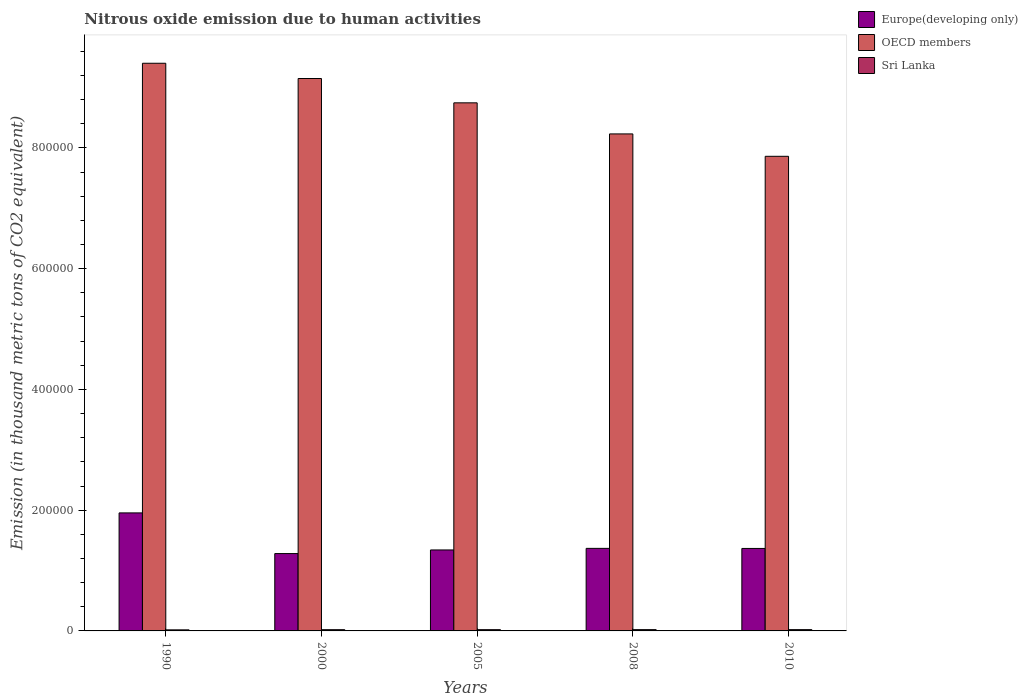How many groups of bars are there?
Give a very brief answer. 5. Are the number of bars per tick equal to the number of legend labels?
Your response must be concise. Yes. What is the label of the 3rd group of bars from the left?
Give a very brief answer. 2005. In how many cases, is the number of bars for a given year not equal to the number of legend labels?
Your answer should be very brief. 0. What is the amount of nitrous oxide emitted in Europe(developing only) in 2010?
Give a very brief answer. 1.37e+05. Across all years, what is the maximum amount of nitrous oxide emitted in Sri Lanka?
Ensure brevity in your answer.  2131.6. Across all years, what is the minimum amount of nitrous oxide emitted in OECD members?
Your response must be concise. 7.86e+05. In which year was the amount of nitrous oxide emitted in Europe(developing only) maximum?
Your response must be concise. 1990. What is the total amount of nitrous oxide emitted in Sri Lanka in the graph?
Offer a very short reply. 1.02e+04. What is the difference between the amount of nitrous oxide emitted in Europe(developing only) in 2005 and that in 2010?
Your answer should be very brief. -2503.4. What is the difference between the amount of nitrous oxide emitted in Sri Lanka in 2008 and the amount of nitrous oxide emitted in OECD members in 1990?
Your response must be concise. -9.38e+05. What is the average amount of nitrous oxide emitted in OECD members per year?
Give a very brief answer. 8.68e+05. In the year 2010, what is the difference between the amount of nitrous oxide emitted in Europe(developing only) and amount of nitrous oxide emitted in OECD members?
Provide a short and direct response. -6.49e+05. In how many years, is the amount of nitrous oxide emitted in Europe(developing only) greater than 360000 thousand metric tons?
Offer a very short reply. 0. What is the ratio of the amount of nitrous oxide emitted in OECD members in 2008 to that in 2010?
Make the answer very short. 1.05. What is the difference between the highest and the second highest amount of nitrous oxide emitted in Sri Lanka?
Offer a terse response. 6.2. What is the difference between the highest and the lowest amount of nitrous oxide emitted in Europe(developing only)?
Ensure brevity in your answer.  6.74e+04. Is the sum of the amount of nitrous oxide emitted in OECD members in 2000 and 2008 greater than the maximum amount of nitrous oxide emitted in Sri Lanka across all years?
Your response must be concise. Yes. What does the 3rd bar from the left in 2000 represents?
Keep it short and to the point. Sri Lanka. What does the 1st bar from the right in 2010 represents?
Ensure brevity in your answer.  Sri Lanka. Are all the bars in the graph horizontal?
Your response must be concise. No. How many years are there in the graph?
Offer a very short reply. 5. Does the graph contain grids?
Your answer should be very brief. No. How many legend labels are there?
Give a very brief answer. 3. What is the title of the graph?
Offer a very short reply. Nitrous oxide emission due to human activities. What is the label or title of the X-axis?
Offer a terse response. Years. What is the label or title of the Y-axis?
Keep it short and to the point. Emission (in thousand metric tons of CO2 equivalent). What is the Emission (in thousand metric tons of CO2 equivalent) in Europe(developing only) in 1990?
Your answer should be very brief. 1.95e+05. What is the Emission (in thousand metric tons of CO2 equivalent) of OECD members in 1990?
Your response must be concise. 9.40e+05. What is the Emission (in thousand metric tons of CO2 equivalent) of Sri Lanka in 1990?
Offer a very short reply. 1759.4. What is the Emission (in thousand metric tons of CO2 equivalent) in Europe(developing only) in 2000?
Provide a short and direct response. 1.28e+05. What is the Emission (in thousand metric tons of CO2 equivalent) in OECD members in 2000?
Offer a terse response. 9.15e+05. What is the Emission (in thousand metric tons of CO2 equivalent) of Sri Lanka in 2000?
Provide a succinct answer. 2044.5. What is the Emission (in thousand metric tons of CO2 equivalent) of Europe(developing only) in 2005?
Keep it short and to the point. 1.34e+05. What is the Emission (in thousand metric tons of CO2 equivalent) of OECD members in 2005?
Offer a terse response. 8.75e+05. What is the Emission (in thousand metric tons of CO2 equivalent) of Sri Lanka in 2005?
Keep it short and to the point. 2094.1. What is the Emission (in thousand metric tons of CO2 equivalent) of Europe(developing only) in 2008?
Your answer should be compact. 1.37e+05. What is the Emission (in thousand metric tons of CO2 equivalent) in OECD members in 2008?
Give a very brief answer. 8.23e+05. What is the Emission (in thousand metric tons of CO2 equivalent) in Sri Lanka in 2008?
Make the answer very short. 2125.4. What is the Emission (in thousand metric tons of CO2 equivalent) in Europe(developing only) in 2010?
Your answer should be very brief. 1.37e+05. What is the Emission (in thousand metric tons of CO2 equivalent) in OECD members in 2010?
Give a very brief answer. 7.86e+05. What is the Emission (in thousand metric tons of CO2 equivalent) in Sri Lanka in 2010?
Keep it short and to the point. 2131.6. Across all years, what is the maximum Emission (in thousand metric tons of CO2 equivalent) of Europe(developing only)?
Ensure brevity in your answer.  1.95e+05. Across all years, what is the maximum Emission (in thousand metric tons of CO2 equivalent) of OECD members?
Your answer should be very brief. 9.40e+05. Across all years, what is the maximum Emission (in thousand metric tons of CO2 equivalent) of Sri Lanka?
Give a very brief answer. 2131.6. Across all years, what is the minimum Emission (in thousand metric tons of CO2 equivalent) in Europe(developing only)?
Your answer should be very brief. 1.28e+05. Across all years, what is the minimum Emission (in thousand metric tons of CO2 equivalent) in OECD members?
Ensure brevity in your answer.  7.86e+05. Across all years, what is the minimum Emission (in thousand metric tons of CO2 equivalent) in Sri Lanka?
Give a very brief answer. 1759.4. What is the total Emission (in thousand metric tons of CO2 equivalent) of Europe(developing only) in the graph?
Make the answer very short. 7.31e+05. What is the total Emission (in thousand metric tons of CO2 equivalent) in OECD members in the graph?
Your answer should be very brief. 4.34e+06. What is the total Emission (in thousand metric tons of CO2 equivalent) in Sri Lanka in the graph?
Your response must be concise. 1.02e+04. What is the difference between the Emission (in thousand metric tons of CO2 equivalent) of Europe(developing only) in 1990 and that in 2000?
Offer a very short reply. 6.74e+04. What is the difference between the Emission (in thousand metric tons of CO2 equivalent) of OECD members in 1990 and that in 2000?
Your response must be concise. 2.52e+04. What is the difference between the Emission (in thousand metric tons of CO2 equivalent) in Sri Lanka in 1990 and that in 2000?
Your answer should be compact. -285.1. What is the difference between the Emission (in thousand metric tons of CO2 equivalent) of Europe(developing only) in 1990 and that in 2005?
Your response must be concise. 6.14e+04. What is the difference between the Emission (in thousand metric tons of CO2 equivalent) in OECD members in 1990 and that in 2005?
Provide a succinct answer. 6.55e+04. What is the difference between the Emission (in thousand metric tons of CO2 equivalent) of Sri Lanka in 1990 and that in 2005?
Provide a short and direct response. -334.7. What is the difference between the Emission (in thousand metric tons of CO2 equivalent) of Europe(developing only) in 1990 and that in 2008?
Offer a terse response. 5.87e+04. What is the difference between the Emission (in thousand metric tons of CO2 equivalent) in OECD members in 1990 and that in 2008?
Your answer should be compact. 1.17e+05. What is the difference between the Emission (in thousand metric tons of CO2 equivalent) of Sri Lanka in 1990 and that in 2008?
Give a very brief answer. -366. What is the difference between the Emission (in thousand metric tons of CO2 equivalent) in Europe(developing only) in 1990 and that in 2010?
Offer a very short reply. 5.89e+04. What is the difference between the Emission (in thousand metric tons of CO2 equivalent) of OECD members in 1990 and that in 2010?
Make the answer very short. 1.54e+05. What is the difference between the Emission (in thousand metric tons of CO2 equivalent) in Sri Lanka in 1990 and that in 2010?
Your answer should be very brief. -372.2. What is the difference between the Emission (in thousand metric tons of CO2 equivalent) of Europe(developing only) in 2000 and that in 2005?
Keep it short and to the point. -5992.3. What is the difference between the Emission (in thousand metric tons of CO2 equivalent) of OECD members in 2000 and that in 2005?
Ensure brevity in your answer.  4.03e+04. What is the difference between the Emission (in thousand metric tons of CO2 equivalent) in Sri Lanka in 2000 and that in 2005?
Make the answer very short. -49.6. What is the difference between the Emission (in thousand metric tons of CO2 equivalent) of Europe(developing only) in 2000 and that in 2008?
Offer a very short reply. -8618.7. What is the difference between the Emission (in thousand metric tons of CO2 equivalent) of OECD members in 2000 and that in 2008?
Offer a terse response. 9.18e+04. What is the difference between the Emission (in thousand metric tons of CO2 equivalent) in Sri Lanka in 2000 and that in 2008?
Your answer should be compact. -80.9. What is the difference between the Emission (in thousand metric tons of CO2 equivalent) of Europe(developing only) in 2000 and that in 2010?
Offer a very short reply. -8495.7. What is the difference between the Emission (in thousand metric tons of CO2 equivalent) of OECD members in 2000 and that in 2010?
Offer a very short reply. 1.29e+05. What is the difference between the Emission (in thousand metric tons of CO2 equivalent) in Sri Lanka in 2000 and that in 2010?
Provide a short and direct response. -87.1. What is the difference between the Emission (in thousand metric tons of CO2 equivalent) in Europe(developing only) in 2005 and that in 2008?
Offer a very short reply. -2626.4. What is the difference between the Emission (in thousand metric tons of CO2 equivalent) of OECD members in 2005 and that in 2008?
Your response must be concise. 5.15e+04. What is the difference between the Emission (in thousand metric tons of CO2 equivalent) in Sri Lanka in 2005 and that in 2008?
Your answer should be compact. -31.3. What is the difference between the Emission (in thousand metric tons of CO2 equivalent) of Europe(developing only) in 2005 and that in 2010?
Your answer should be compact. -2503.4. What is the difference between the Emission (in thousand metric tons of CO2 equivalent) in OECD members in 2005 and that in 2010?
Ensure brevity in your answer.  8.86e+04. What is the difference between the Emission (in thousand metric tons of CO2 equivalent) in Sri Lanka in 2005 and that in 2010?
Offer a terse response. -37.5. What is the difference between the Emission (in thousand metric tons of CO2 equivalent) in Europe(developing only) in 2008 and that in 2010?
Offer a very short reply. 123. What is the difference between the Emission (in thousand metric tons of CO2 equivalent) in OECD members in 2008 and that in 2010?
Provide a succinct answer. 3.71e+04. What is the difference between the Emission (in thousand metric tons of CO2 equivalent) in Europe(developing only) in 1990 and the Emission (in thousand metric tons of CO2 equivalent) in OECD members in 2000?
Your answer should be compact. -7.19e+05. What is the difference between the Emission (in thousand metric tons of CO2 equivalent) of Europe(developing only) in 1990 and the Emission (in thousand metric tons of CO2 equivalent) of Sri Lanka in 2000?
Offer a terse response. 1.93e+05. What is the difference between the Emission (in thousand metric tons of CO2 equivalent) in OECD members in 1990 and the Emission (in thousand metric tons of CO2 equivalent) in Sri Lanka in 2000?
Ensure brevity in your answer.  9.38e+05. What is the difference between the Emission (in thousand metric tons of CO2 equivalent) of Europe(developing only) in 1990 and the Emission (in thousand metric tons of CO2 equivalent) of OECD members in 2005?
Your response must be concise. -6.79e+05. What is the difference between the Emission (in thousand metric tons of CO2 equivalent) of Europe(developing only) in 1990 and the Emission (in thousand metric tons of CO2 equivalent) of Sri Lanka in 2005?
Keep it short and to the point. 1.93e+05. What is the difference between the Emission (in thousand metric tons of CO2 equivalent) of OECD members in 1990 and the Emission (in thousand metric tons of CO2 equivalent) of Sri Lanka in 2005?
Your answer should be very brief. 9.38e+05. What is the difference between the Emission (in thousand metric tons of CO2 equivalent) in Europe(developing only) in 1990 and the Emission (in thousand metric tons of CO2 equivalent) in OECD members in 2008?
Keep it short and to the point. -6.28e+05. What is the difference between the Emission (in thousand metric tons of CO2 equivalent) in Europe(developing only) in 1990 and the Emission (in thousand metric tons of CO2 equivalent) in Sri Lanka in 2008?
Give a very brief answer. 1.93e+05. What is the difference between the Emission (in thousand metric tons of CO2 equivalent) of OECD members in 1990 and the Emission (in thousand metric tons of CO2 equivalent) of Sri Lanka in 2008?
Provide a short and direct response. 9.38e+05. What is the difference between the Emission (in thousand metric tons of CO2 equivalent) in Europe(developing only) in 1990 and the Emission (in thousand metric tons of CO2 equivalent) in OECD members in 2010?
Give a very brief answer. -5.91e+05. What is the difference between the Emission (in thousand metric tons of CO2 equivalent) in Europe(developing only) in 1990 and the Emission (in thousand metric tons of CO2 equivalent) in Sri Lanka in 2010?
Your response must be concise. 1.93e+05. What is the difference between the Emission (in thousand metric tons of CO2 equivalent) of OECD members in 1990 and the Emission (in thousand metric tons of CO2 equivalent) of Sri Lanka in 2010?
Offer a terse response. 9.38e+05. What is the difference between the Emission (in thousand metric tons of CO2 equivalent) in Europe(developing only) in 2000 and the Emission (in thousand metric tons of CO2 equivalent) in OECD members in 2005?
Keep it short and to the point. -7.47e+05. What is the difference between the Emission (in thousand metric tons of CO2 equivalent) of Europe(developing only) in 2000 and the Emission (in thousand metric tons of CO2 equivalent) of Sri Lanka in 2005?
Your answer should be compact. 1.26e+05. What is the difference between the Emission (in thousand metric tons of CO2 equivalent) of OECD members in 2000 and the Emission (in thousand metric tons of CO2 equivalent) of Sri Lanka in 2005?
Your response must be concise. 9.13e+05. What is the difference between the Emission (in thousand metric tons of CO2 equivalent) in Europe(developing only) in 2000 and the Emission (in thousand metric tons of CO2 equivalent) in OECD members in 2008?
Your answer should be very brief. -6.95e+05. What is the difference between the Emission (in thousand metric tons of CO2 equivalent) in Europe(developing only) in 2000 and the Emission (in thousand metric tons of CO2 equivalent) in Sri Lanka in 2008?
Make the answer very short. 1.26e+05. What is the difference between the Emission (in thousand metric tons of CO2 equivalent) of OECD members in 2000 and the Emission (in thousand metric tons of CO2 equivalent) of Sri Lanka in 2008?
Your answer should be very brief. 9.13e+05. What is the difference between the Emission (in thousand metric tons of CO2 equivalent) of Europe(developing only) in 2000 and the Emission (in thousand metric tons of CO2 equivalent) of OECD members in 2010?
Give a very brief answer. -6.58e+05. What is the difference between the Emission (in thousand metric tons of CO2 equivalent) in Europe(developing only) in 2000 and the Emission (in thousand metric tons of CO2 equivalent) in Sri Lanka in 2010?
Make the answer very short. 1.26e+05. What is the difference between the Emission (in thousand metric tons of CO2 equivalent) of OECD members in 2000 and the Emission (in thousand metric tons of CO2 equivalent) of Sri Lanka in 2010?
Your answer should be very brief. 9.13e+05. What is the difference between the Emission (in thousand metric tons of CO2 equivalent) in Europe(developing only) in 2005 and the Emission (in thousand metric tons of CO2 equivalent) in OECD members in 2008?
Offer a terse response. -6.89e+05. What is the difference between the Emission (in thousand metric tons of CO2 equivalent) of Europe(developing only) in 2005 and the Emission (in thousand metric tons of CO2 equivalent) of Sri Lanka in 2008?
Your answer should be very brief. 1.32e+05. What is the difference between the Emission (in thousand metric tons of CO2 equivalent) in OECD members in 2005 and the Emission (in thousand metric tons of CO2 equivalent) in Sri Lanka in 2008?
Provide a succinct answer. 8.72e+05. What is the difference between the Emission (in thousand metric tons of CO2 equivalent) of Europe(developing only) in 2005 and the Emission (in thousand metric tons of CO2 equivalent) of OECD members in 2010?
Ensure brevity in your answer.  -6.52e+05. What is the difference between the Emission (in thousand metric tons of CO2 equivalent) in Europe(developing only) in 2005 and the Emission (in thousand metric tons of CO2 equivalent) in Sri Lanka in 2010?
Provide a succinct answer. 1.32e+05. What is the difference between the Emission (in thousand metric tons of CO2 equivalent) of OECD members in 2005 and the Emission (in thousand metric tons of CO2 equivalent) of Sri Lanka in 2010?
Ensure brevity in your answer.  8.72e+05. What is the difference between the Emission (in thousand metric tons of CO2 equivalent) of Europe(developing only) in 2008 and the Emission (in thousand metric tons of CO2 equivalent) of OECD members in 2010?
Provide a succinct answer. -6.49e+05. What is the difference between the Emission (in thousand metric tons of CO2 equivalent) of Europe(developing only) in 2008 and the Emission (in thousand metric tons of CO2 equivalent) of Sri Lanka in 2010?
Give a very brief answer. 1.35e+05. What is the difference between the Emission (in thousand metric tons of CO2 equivalent) in OECD members in 2008 and the Emission (in thousand metric tons of CO2 equivalent) in Sri Lanka in 2010?
Make the answer very short. 8.21e+05. What is the average Emission (in thousand metric tons of CO2 equivalent) of Europe(developing only) per year?
Ensure brevity in your answer.  1.46e+05. What is the average Emission (in thousand metric tons of CO2 equivalent) of OECD members per year?
Make the answer very short. 8.68e+05. What is the average Emission (in thousand metric tons of CO2 equivalent) of Sri Lanka per year?
Provide a succinct answer. 2031. In the year 1990, what is the difference between the Emission (in thousand metric tons of CO2 equivalent) in Europe(developing only) and Emission (in thousand metric tons of CO2 equivalent) in OECD members?
Provide a short and direct response. -7.45e+05. In the year 1990, what is the difference between the Emission (in thousand metric tons of CO2 equivalent) in Europe(developing only) and Emission (in thousand metric tons of CO2 equivalent) in Sri Lanka?
Your answer should be compact. 1.94e+05. In the year 1990, what is the difference between the Emission (in thousand metric tons of CO2 equivalent) in OECD members and Emission (in thousand metric tons of CO2 equivalent) in Sri Lanka?
Give a very brief answer. 9.38e+05. In the year 2000, what is the difference between the Emission (in thousand metric tons of CO2 equivalent) in Europe(developing only) and Emission (in thousand metric tons of CO2 equivalent) in OECD members?
Your answer should be compact. -7.87e+05. In the year 2000, what is the difference between the Emission (in thousand metric tons of CO2 equivalent) of Europe(developing only) and Emission (in thousand metric tons of CO2 equivalent) of Sri Lanka?
Make the answer very short. 1.26e+05. In the year 2000, what is the difference between the Emission (in thousand metric tons of CO2 equivalent) of OECD members and Emission (in thousand metric tons of CO2 equivalent) of Sri Lanka?
Make the answer very short. 9.13e+05. In the year 2005, what is the difference between the Emission (in thousand metric tons of CO2 equivalent) in Europe(developing only) and Emission (in thousand metric tons of CO2 equivalent) in OECD members?
Provide a short and direct response. -7.41e+05. In the year 2005, what is the difference between the Emission (in thousand metric tons of CO2 equivalent) of Europe(developing only) and Emission (in thousand metric tons of CO2 equivalent) of Sri Lanka?
Your answer should be very brief. 1.32e+05. In the year 2005, what is the difference between the Emission (in thousand metric tons of CO2 equivalent) in OECD members and Emission (in thousand metric tons of CO2 equivalent) in Sri Lanka?
Your answer should be compact. 8.73e+05. In the year 2008, what is the difference between the Emission (in thousand metric tons of CO2 equivalent) of Europe(developing only) and Emission (in thousand metric tons of CO2 equivalent) of OECD members?
Offer a very short reply. -6.86e+05. In the year 2008, what is the difference between the Emission (in thousand metric tons of CO2 equivalent) in Europe(developing only) and Emission (in thousand metric tons of CO2 equivalent) in Sri Lanka?
Make the answer very short. 1.35e+05. In the year 2008, what is the difference between the Emission (in thousand metric tons of CO2 equivalent) of OECD members and Emission (in thousand metric tons of CO2 equivalent) of Sri Lanka?
Keep it short and to the point. 8.21e+05. In the year 2010, what is the difference between the Emission (in thousand metric tons of CO2 equivalent) in Europe(developing only) and Emission (in thousand metric tons of CO2 equivalent) in OECD members?
Ensure brevity in your answer.  -6.49e+05. In the year 2010, what is the difference between the Emission (in thousand metric tons of CO2 equivalent) of Europe(developing only) and Emission (in thousand metric tons of CO2 equivalent) of Sri Lanka?
Your answer should be very brief. 1.34e+05. In the year 2010, what is the difference between the Emission (in thousand metric tons of CO2 equivalent) of OECD members and Emission (in thousand metric tons of CO2 equivalent) of Sri Lanka?
Your response must be concise. 7.84e+05. What is the ratio of the Emission (in thousand metric tons of CO2 equivalent) of Europe(developing only) in 1990 to that in 2000?
Your answer should be compact. 1.53. What is the ratio of the Emission (in thousand metric tons of CO2 equivalent) of OECD members in 1990 to that in 2000?
Make the answer very short. 1.03. What is the ratio of the Emission (in thousand metric tons of CO2 equivalent) of Sri Lanka in 1990 to that in 2000?
Give a very brief answer. 0.86. What is the ratio of the Emission (in thousand metric tons of CO2 equivalent) of Europe(developing only) in 1990 to that in 2005?
Provide a short and direct response. 1.46. What is the ratio of the Emission (in thousand metric tons of CO2 equivalent) in OECD members in 1990 to that in 2005?
Your answer should be compact. 1.07. What is the ratio of the Emission (in thousand metric tons of CO2 equivalent) in Sri Lanka in 1990 to that in 2005?
Make the answer very short. 0.84. What is the ratio of the Emission (in thousand metric tons of CO2 equivalent) of Europe(developing only) in 1990 to that in 2008?
Offer a very short reply. 1.43. What is the ratio of the Emission (in thousand metric tons of CO2 equivalent) of OECD members in 1990 to that in 2008?
Offer a very short reply. 1.14. What is the ratio of the Emission (in thousand metric tons of CO2 equivalent) of Sri Lanka in 1990 to that in 2008?
Your response must be concise. 0.83. What is the ratio of the Emission (in thousand metric tons of CO2 equivalent) in Europe(developing only) in 1990 to that in 2010?
Your answer should be very brief. 1.43. What is the ratio of the Emission (in thousand metric tons of CO2 equivalent) in OECD members in 1990 to that in 2010?
Give a very brief answer. 1.2. What is the ratio of the Emission (in thousand metric tons of CO2 equivalent) of Sri Lanka in 1990 to that in 2010?
Your response must be concise. 0.83. What is the ratio of the Emission (in thousand metric tons of CO2 equivalent) in Europe(developing only) in 2000 to that in 2005?
Make the answer very short. 0.96. What is the ratio of the Emission (in thousand metric tons of CO2 equivalent) in OECD members in 2000 to that in 2005?
Provide a succinct answer. 1.05. What is the ratio of the Emission (in thousand metric tons of CO2 equivalent) in Sri Lanka in 2000 to that in 2005?
Offer a very short reply. 0.98. What is the ratio of the Emission (in thousand metric tons of CO2 equivalent) in Europe(developing only) in 2000 to that in 2008?
Provide a short and direct response. 0.94. What is the ratio of the Emission (in thousand metric tons of CO2 equivalent) in OECD members in 2000 to that in 2008?
Provide a succinct answer. 1.11. What is the ratio of the Emission (in thousand metric tons of CO2 equivalent) in Sri Lanka in 2000 to that in 2008?
Your answer should be compact. 0.96. What is the ratio of the Emission (in thousand metric tons of CO2 equivalent) in Europe(developing only) in 2000 to that in 2010?
Make the answer very short. 0.94. What is the ratio of the Emission (in thousand metric tons of CO2 equivalent) in OECD members in 2000 to that in 2010?
Keep it short and to the point. 1.16. What is the ratio of the Emission (in thousand metric tons of CO2 equivalent) of Sri Lanka in 2000 to that in 2010?
Provide a succinct answer. 0.96. What is the ratio of the Emission (in thousand metric tons of CO2 equivalent) of Europe(developing only) in 2005 to that in 2008?
Offer a very short reply. 0.98. What is the ratio of the Emission (in thousand metric tons of CO2 equivalent) of OECD members in 2005 to that in 2008?
Offer a very short reply. 1.06. What is the ratio of the Emission (in thousand metric tons of CO2 equivalent) of Europe(developing only) in 2005 to that in 2010?
Make the answer very short. 0.98. What is the ratio of the Emission (in thousand metric tons of CO2 equivalent) of OECD members in 2005 to that in 2010?
Make the answer very short. 1.11. What is the ratio of the Emission (in thousand metric tons of CO2 equivalent) in Sri Lanka in 2005 to that in 2010?
Your answer should be compact. 0.98. What is the ratio of the Emission (in thousand metric tons of CO2 equivalent) in Europe(developing only) in 2008 to that in 2010?
Your answer should be compact. 1. What is the ratio of the Emission (in thousand metric tons of CO2 equivalent) of OECD members in 2008 to that in 2010?
Offer a terse response. 1.05. What is the ratio of the Emission (in thousand metric tons of CO2 equivalent) of Sri Lanka in 2008 to that in 2010?
Make the answer very short. 1. What is the difference between the highest and the second highest Emission (in thousand metric tons of CO2 equivalent) in Europe(developing only)?
Provide a succinct answer. 5.87e+04. What is the difference between the highest and the second highest Emission (in thousand metric tons of CO2 equivalent) in OECD members?
Provide a succinct answer. 2.52e+04. What is the difference between the highest and the second highest Emission (in thousand metric tons of CO2 equivalent) of Sri Lanka?
Provide a succinct answer. 6.2. What is the difference between the highest and the lowest Emission (in thousand metric tons of CO2 equivalent) of Europe(developing only)?
Offer a terse response. 6.74e+04. What is the difference between the highest and the lowest Emission (in thousand metric tons of CO2 equivalent) of OECD members?
Your response must be concise. 1.54e+05. What is the difference between the highest and the lowest Emission (in thousand metric tons of CO2 equivalent) in Sri Lanka?
Your answer should be compact. 372.2. 